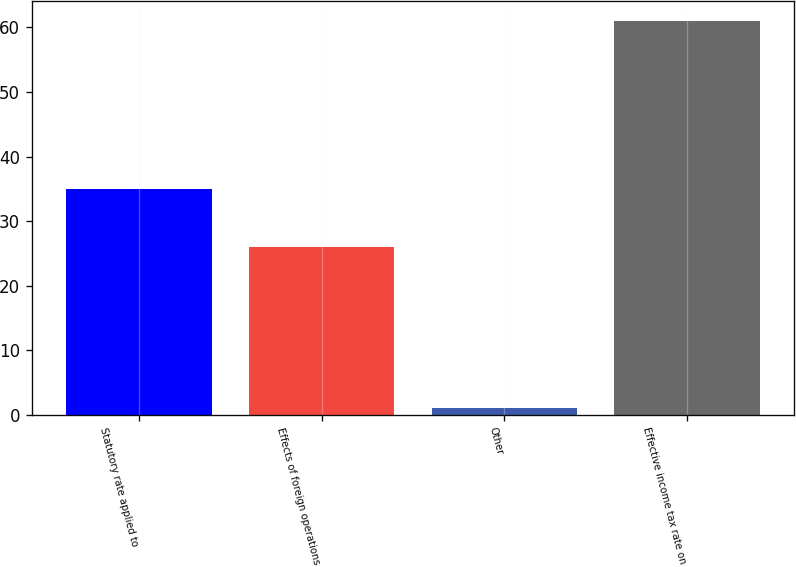<chart> <loc_0><loc_0><loc_500><loc_500><bar_chart><fcel>Statutory rate applied to<fcel>Effects of foreign operations<fcel>Other<fcel>Effective income tax rate on<nl><fcel>35<fcel>26<fcel>1<fcel>61<nl></chart> 